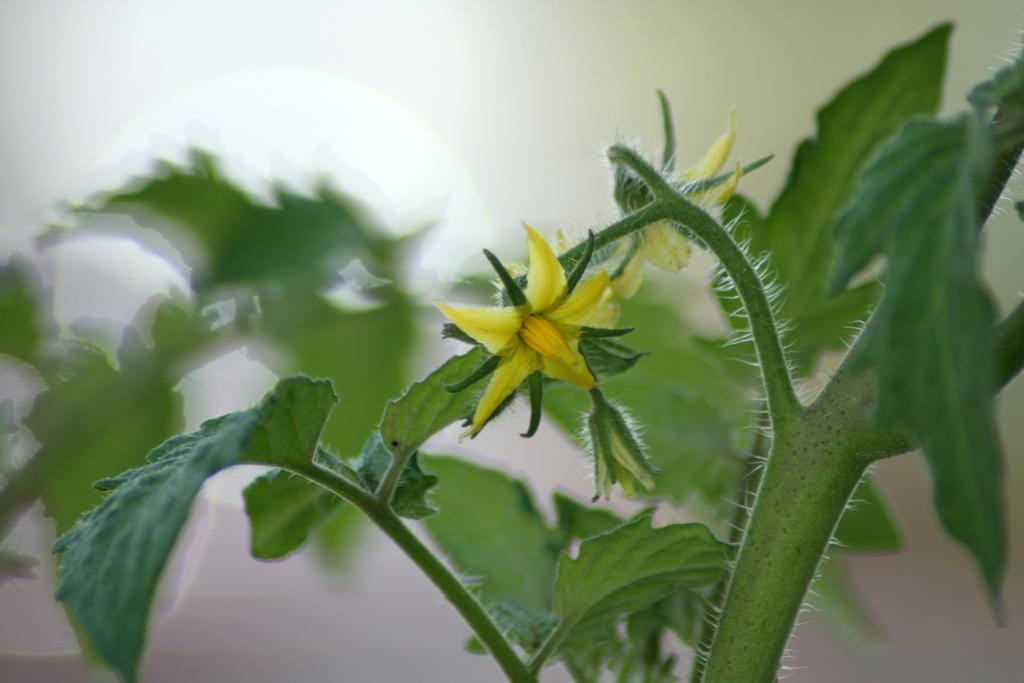In one or two sentences, can you explain what this image depicts? In this image in the foreground there is a plant, and in the background there is a wall. 